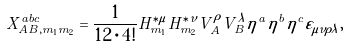Convert formula to latex. <formula><loc_0><loc_0><loc_500><loc_500>X _ { A B , m _ { 1 } m _ { 2 } } ^ { a b c } = \frac { 1 } { 1 2 \cdot 4 ! } H _ { m _ { 1 } } ^ { \ast \mu } H _ { m _ { 2 } } ^ { \ast \nu } V _ { A } ^ { \rho } V _ { B } ^ { \lambda } \eta ^ { a } \eta ^ { b } \eta ^ { c } \varepsilon _ { \mu \nu \rho \lambda } ,</formula> 